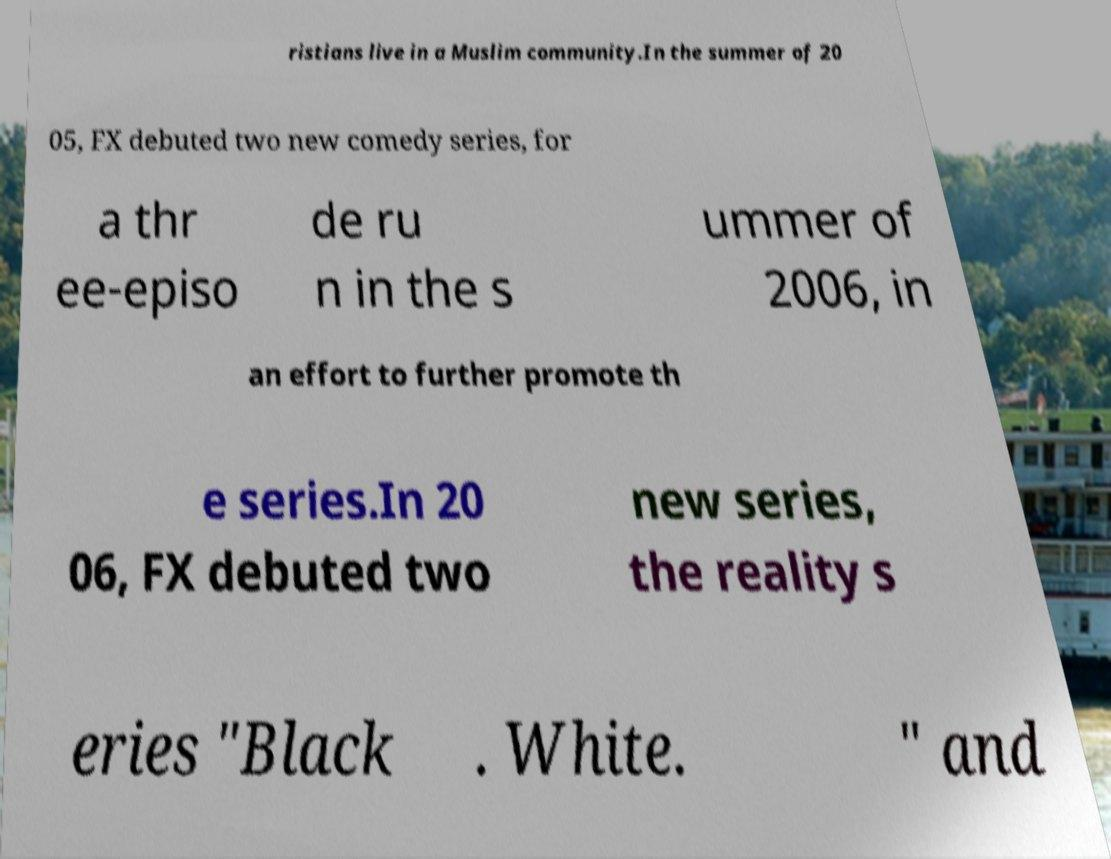I need the written content from this picture converted into text. Can you do that? ristians live in a Muslim community.In the summer of 20 05, FX debuted two new comedy series, for a thr ee-episo de ru n in the s ummer of 2006, in an effort to further promote th e series.In 20 06, FX debuted two new series, the reality s eries "Black . White. " and 